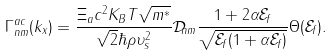<formula> <loc_0><loc_0><loc_500><loc_500>\Gamma _ { n m } ^ { a c } ( k _ { x } ) = \frac { \Xi _ { a } c ^ { 2 } K _ { B } T \sqrt { m ^ { * } } } { \sqrt { 2 } \hbar { \rho } \upsilon _ { s } ^ { 2 } } \mathcal { D } _ { n m } \frac { 1 + 2 \alpha \mathcal { E } _ { f } } { \sqrt { \mathcal { E } _ { f } ( 1 + \alpha \mathcal { E } _ { f } ) } } \Theta ( \mathcal { E } _ { f } ) .</formula> 